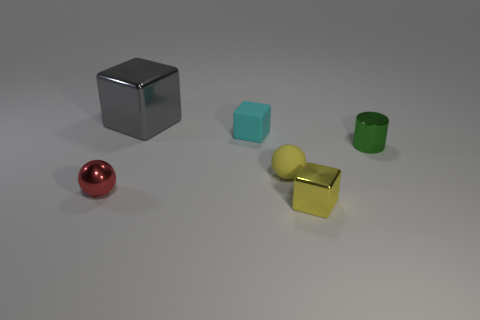Is the number of small shiny spheres that are on the right side of the tiny red sphere greater than the number of spheres in front of the small yellow metallic thing?
Provide a succinct answer. No. Is the small red thing made of the same material as the tiny yellow sphere?
Offer a very short reply. No. What number of small shiny balls are behind the small rubber object behind the small green object?
Your answer should be very brief. 0. Is the color of the small cube in front of the small cyan rubber cube the same as the rubber sphere?
Your answer should be very brief. Yes. What number of objects are either big blue blocks or spheres left of the big gray thing?
Provide a succinct answer. 1. There is a metal thing to the left of the gray metallic cube; is it the same shape as the matte thing in front of the small green object?
Your answer should be very brief. Yes. Are there any other things of the same color as the metal cylinder?
Give a very brief answer. No. What shape is the big object that is the same material as the yellow block?
Ensure brevity in your answer.  Cube. There is a tiny thing that is in front of the tiny green cylinder and on the right side of the rubber sphere; what material is it made of?
Your answer should be very brief. Metal. Is there any other thing that has the same size as the gray cube?
Your response must be concise. No. 